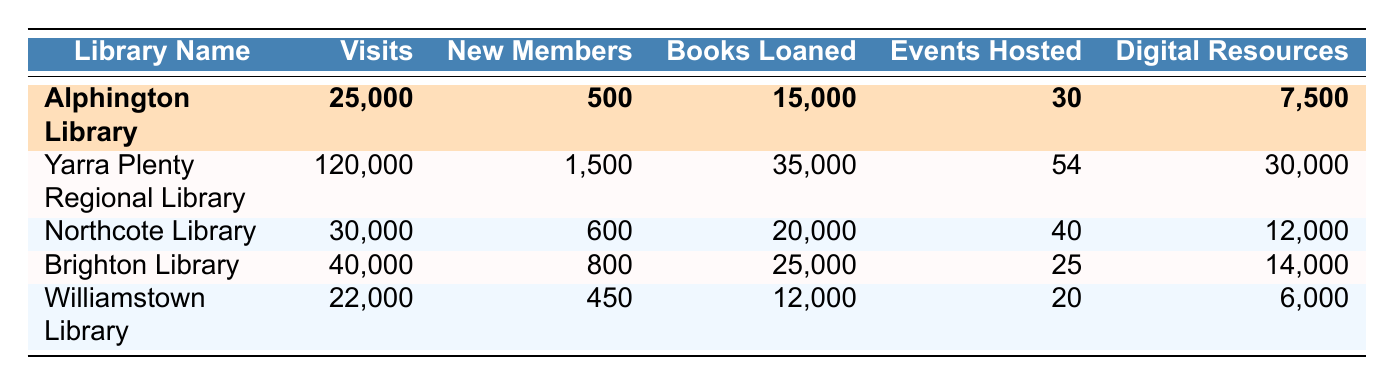What is the total number of visits to Alphington Library in 2022? The visits for Alphington Library are specified as 25,000 in the table.
Answer: 25,000 How many new members did Alphington Library gain in 2022? The table indicates that Alphington Library gained 500 new members throughout the year.
Answer: 500 Which library hosted the most events in 2022? By comparing the events hosted by each library, Yarra Plenty Regional Library hosted the most events, totaling 54.
Answer: Yarra Plenty Regional Library How many more books were loaned by Yarra Plenty Regional Library than by Alphington Library? Yarra Plenty Regional Library loaned 35,000 books, while Alphington Library loaned 15,000 books. The difference is 35,000 - 15,000 = 20,000.
Answer: 20,000 What is the average number of digital resources accessed across all libraries? The total number of digital resources accessed is the sum of each library's values: 7,500 + 30,000 + 12,000 + 14,000 + 6,000 = 69,500. Dividing this by the number of libraries (5), the average is 69,500 / 5 = 13,900.
Answer: 13,900 Is it true that the Alphington Library had more visits than Williamstown Library? According to the table, Alphington Library had 25,000 visits while Williamstown Library had 22,000 visits, indicating that Alphington Library did indeed have more visits.
Answer: Yes What percentage of the total visits were made to Alphington Library? The total visits across all libraries are 25,000 + 120,000 + 30,000 + 40,000 + 22,000 = 237,000. The percentage for Alphington Library is (25,000 / 237,000) * 100 ≈ 10.55%.
Answer: Approximately 10.55% Which library had the least number of new members in 2022? By examining the new members for each library, Williamstown Library had the least with 450 new members.
Answer: Williamstown Library If we consider the total books loaned, how much more than the books loaned by Northcote Library did Brighton Library loan? Brighton Library loaned 25,000 books and Northcote Library loaned 20,000 books. The difference is 25,000 - 20,000 = 5,000.
Answer: 5,000 What is the total number of events hosted by all libraries combined? By adding the events hosted: 30 (Alphington) + 54 (Yarra Plenty Regional) + 40 (Northcote) + 25 (Brighton) + 20 (Williamstown) = 169 events total.
Answer: 169 